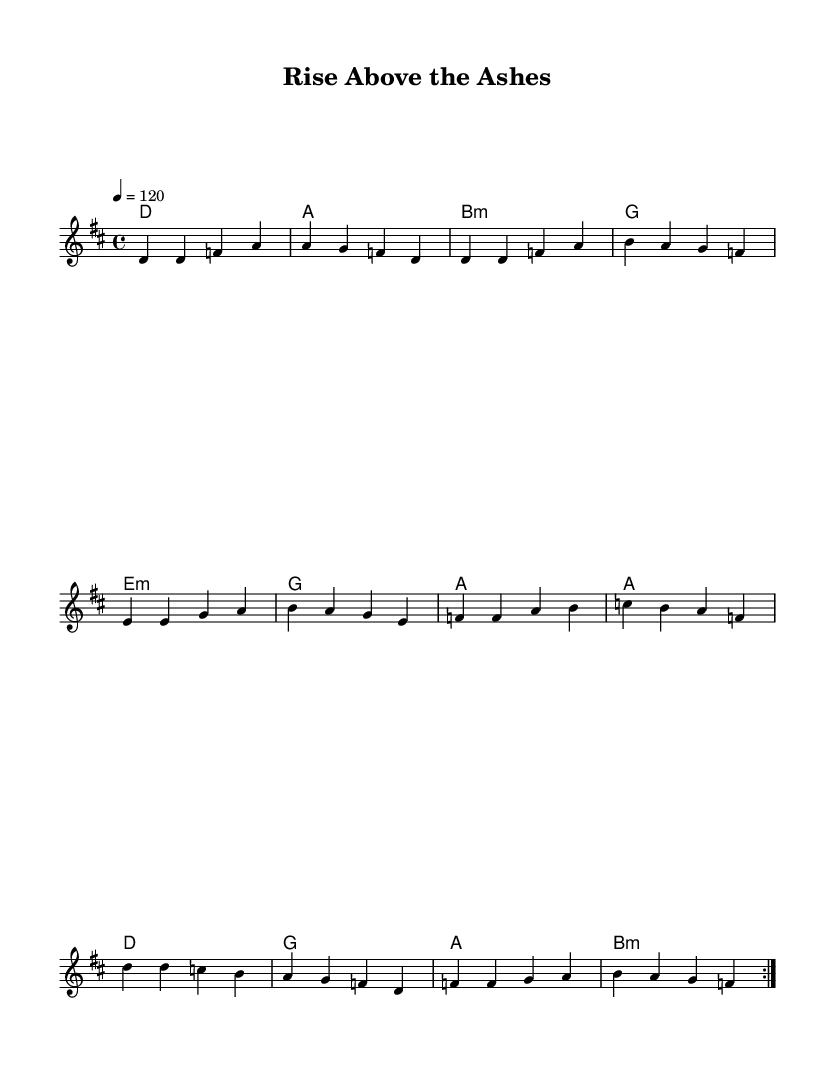What is the key signature of this music? The key signature is indicated at the beginning of the sheet music, showing one sharp (F#), which corresponds to D major.
Answer: D major What is the time signature of this music? The time signature appears at the beginning and shows a 4 over 4, indicating four beats in each measure.
Answer: 4/4 What is the tempo of this piece? The tempo marking indicates the speed of the piece, set at 120 beats per minute (BPM), which is noted in the tempo indication.
Answer: 120 How many measures are in the verse section? The verse section contains 4 measures, counted by identifying the bar lines and counting from the start to the end of this specific section.
Answer: 4 What is the first lyric of the chorus? To find the first lyric of the chorus, check the lyrics under the music and identify the first word of the chorus section. It starts with "I'll".
Answer: I'll How many times is the verse repeated? The repeat sign in the musical notation indicates that the verse section is to be repeated two times, which is noted at the beginning of the section.
Answer: 2 What is the harmony for the pre-chorus section? The harmony for the pre-chorus is indicated under the notes in the chord names section, showing the progression of chords, which includes e minor, g, a, and a.
Answer: e minor, g, a, a 